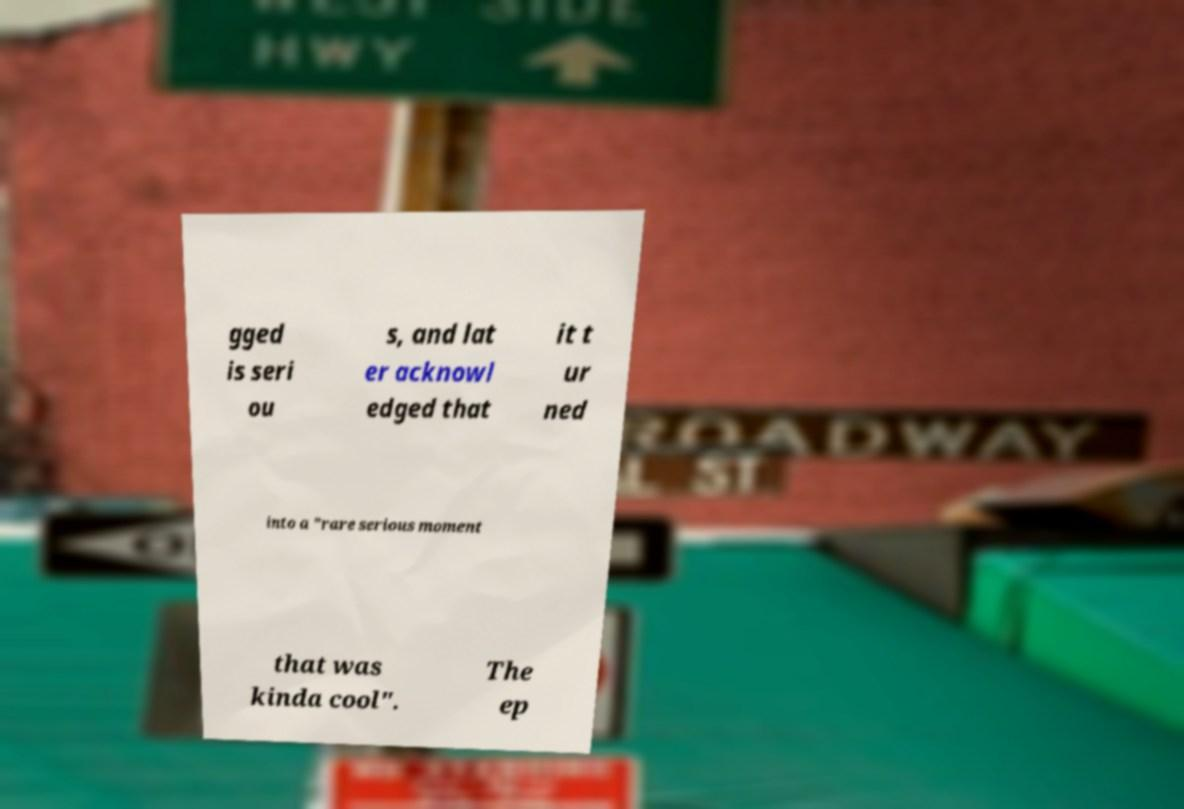There's text embedded in this image that I need extracted. Can you transcribe it verbatim? gged is seri ou s, and lat er acknowl edged that it t ur ned into a "rare serious moment that was kinda cool". The ep 